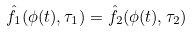Convert formula to latex. <formula><loc_0><loc_0><loc_500><loc_500>\hat { f } _ { 1 } ( \phi ( t ) , \tau _ { 1 } ) = \hat { f } _ { 2 } ( \phi ( t ) , \tau _ { 2 } )</formula> 